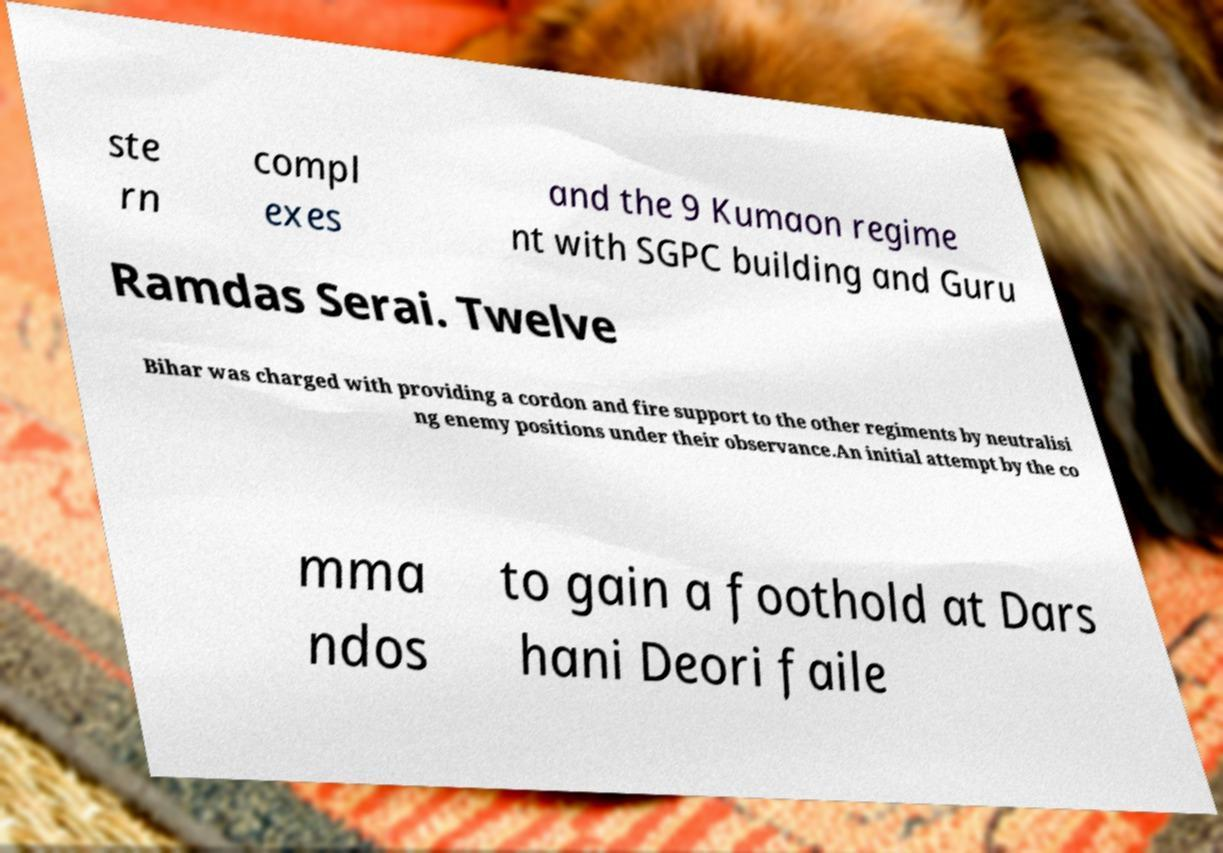There's text embedded in this image that I need extracted. Can you transcribe it verbatim? ste rn compl exes and the 9 Kumaon regime nt with SGPC building and Guru Ramdas Serai. Twelve Bihar was charged with providing a cordon and fire support to the other regiments by neutralisi ng enemy positions under their observance.An initial attempt by the co mma ndos to gain a foothold at Dars hani Deori faile 